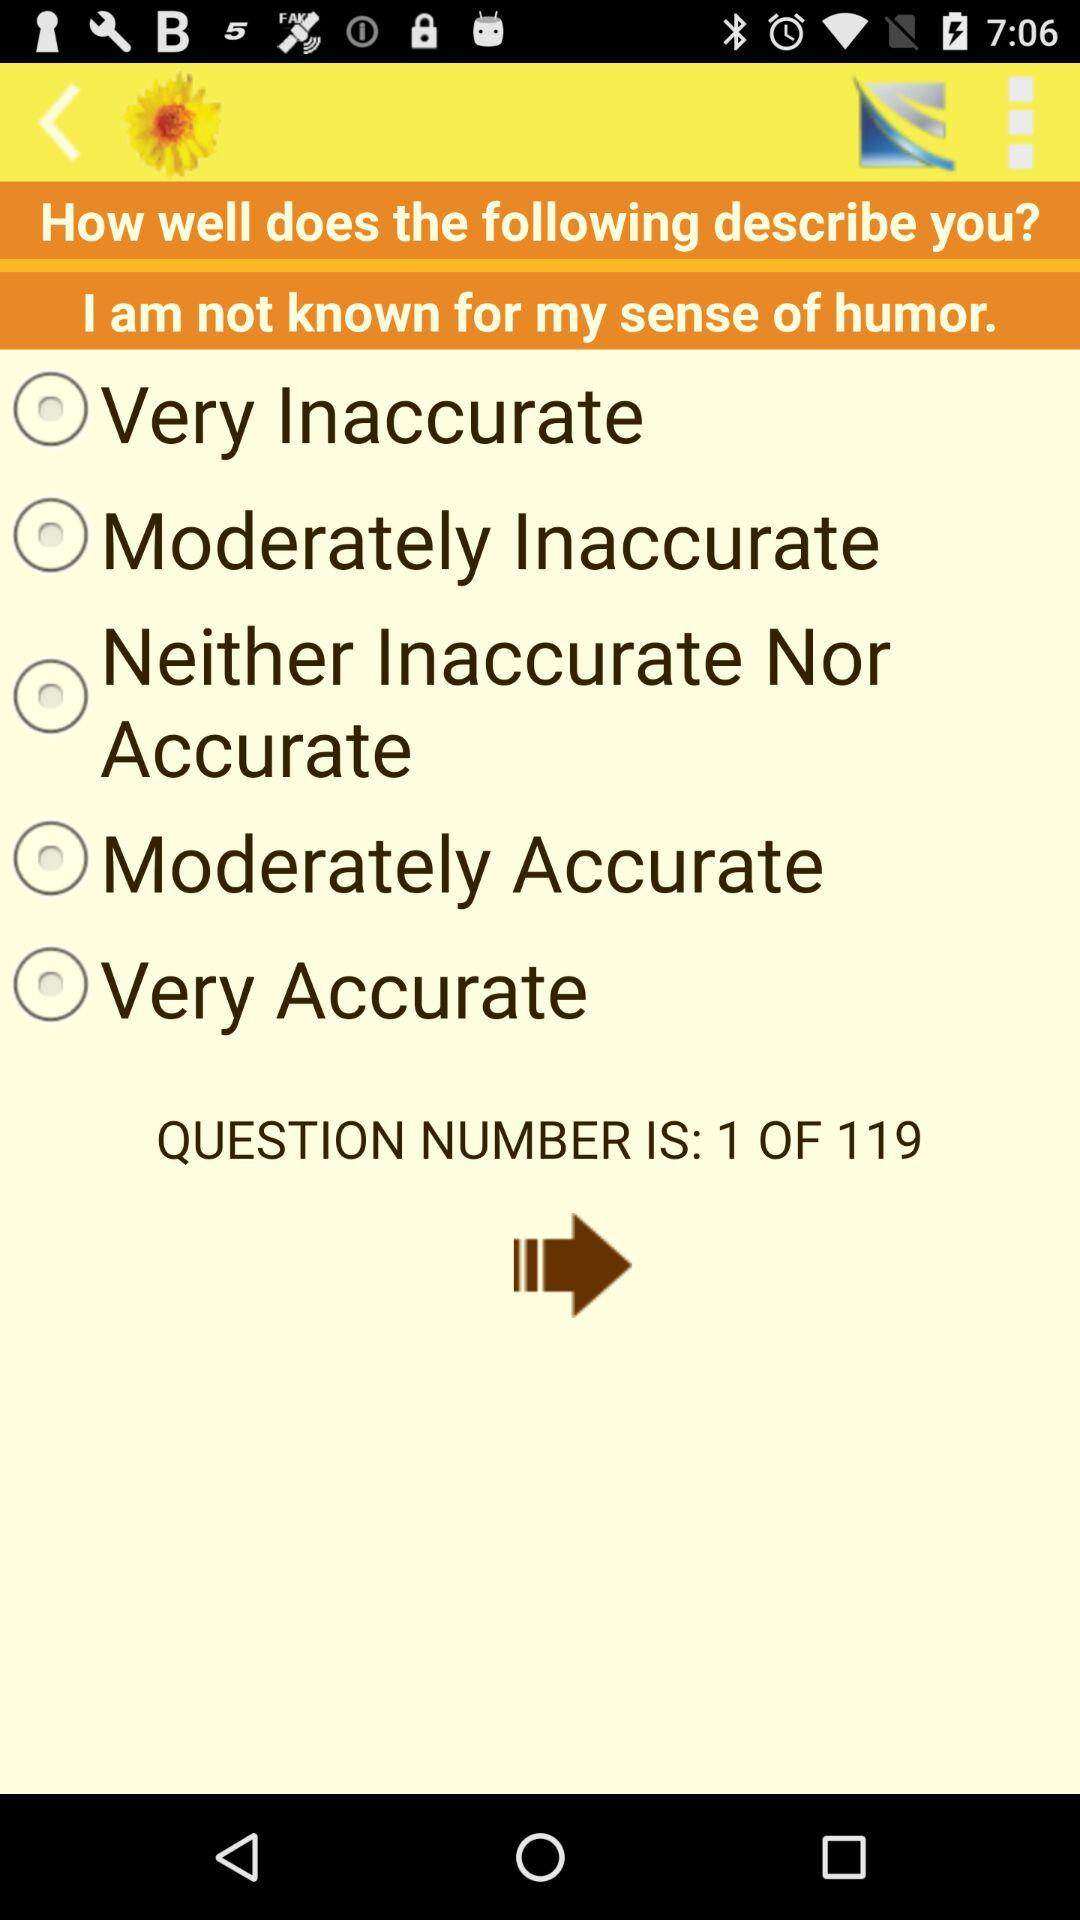On which question number is the person? The person is on question number 1. 